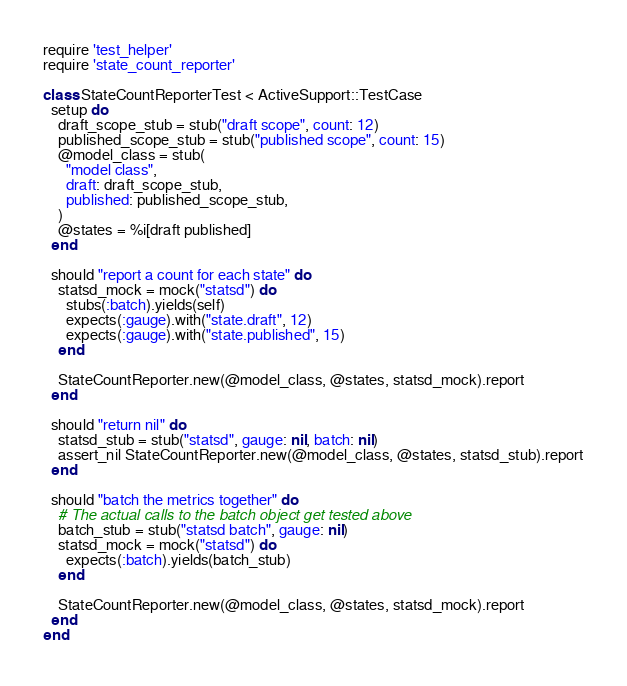Convert code to text. <code><loc_0><loc_0><loc_500><loc_500><_Ruby_>require 'test_helper'
require 'state_count_reporter'

class StateCountReporterTest < ActiveSupport::TestCase
  setup do
    draft_scope_stub = stub("draft scope", count: 12)
    published_scope_stub = stub("published scope", count: 15)
    @model_class = stub(
      "model class",
      draft: draft_scope_stub,
      published: published_scope_stub,
    )
    @states = %i[draft published]
  end

  should "report a count for each state" do
    statsd_mock = mock("statsd") do
      stubs(:batch).yields(self)
      expects(:gauge).with("state.draft", 12)
      expects(:gauge).with("state.published", 15)
    end

    StateCountReporter.new(@model_class, @states, statsd_mock).report
  end

  should "return nil" do
    statsd_stub = stub("statsd", gauge: nil, batch: nil)
    assert_nil StateCountReporter.new(@model_class, @states, statsd_stub).report
  end

  should "batch the metrics together" do
    # The actual calls to the batch object get tested above
    batch_stub = stub("statsd batch", gauge: nil)
    statsd_mock = mock("statsd") do
      expects(:batch).yields(batch_stub)
    end

    StateCountReporter.new(@model_class, @states, statsd_mock).report
  end
end
</code> 